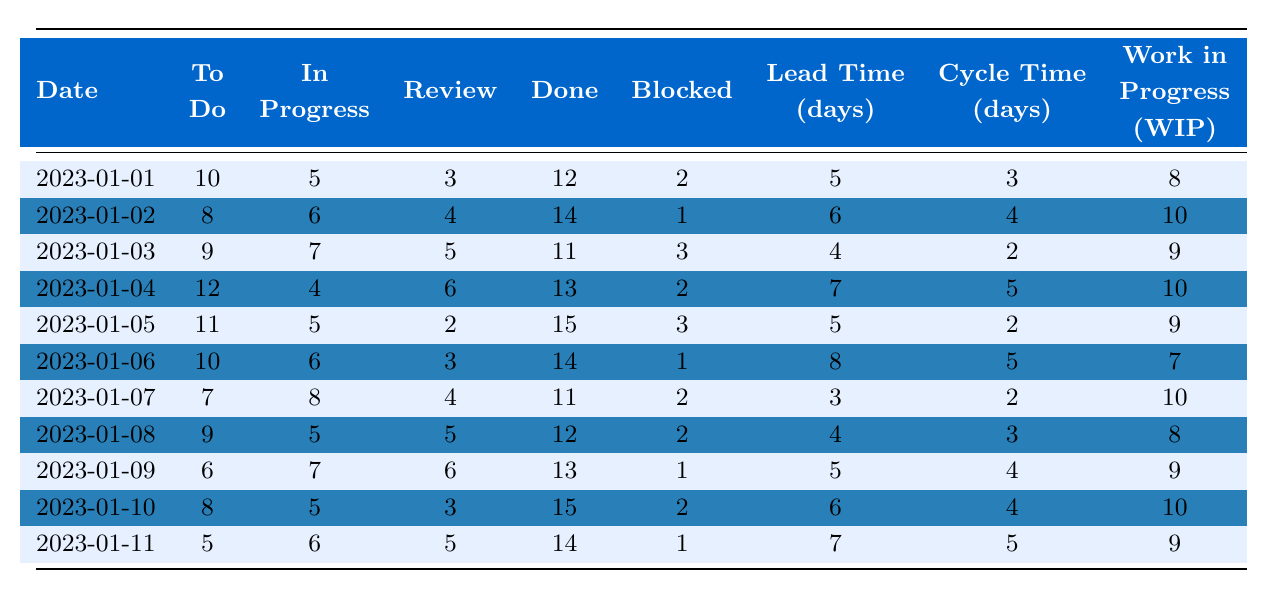What is the total number of tasks marked as "Done" on January 5, 2023? Referring to the table, the value listed under "Done" for January 5, 2023, is 15.
Answer: 15 What was the number of blocked tasks on January 9, 2023? The table shows that there was 1 task marked as "Blocked" on January 9, 2023.
Answer: 1 What was the average "Lead Time" for the tasks over the recorded days? To find the average, sum the "Lead Time" values: (5 + 6 + 4 + 7 + 5 + 8 + 3 + 4 + 5 + 6 + 7) = 60. There are 11 days, so the average is 60 / 11 ≈ 5.45.
Answer: 5.45 On which date was the highest "Cycle Time" recorded? Checking the "Cycle Time" values, the highest recorded value is 8 days on January 6, 2023, where it is listed.
Answer: January 6, 2023 How did the number of "To Do" tasks change from January 1 to January 11? On January 1, there were 10 "To Do" tasks, and on January 11, there were 5 "To Do" tasks. The change is 10 - 5 = 5 fewer tasks.
Answer: 5 fewer tasks What is the total number of tasks across all stages on January 4, 2023? The total is calculated by summing the values in each column on January 4, 2023: (12 + 4 + 6 + 13 + 2) = 37 tasks.
Answer: 37 tasks Was there ever a day when the "Work in Progress (WIP)" was less than 8? Checking the table, on January 6, there were 7 tasks in "Work in Progress," confirming that it was indeed below 8.
Answer: Yes What was the day with the highest number of "In Progress" tasks? The highest "In Progress" count can be found on January 7, 2023, where it lists 8 tasks.
Answer: January 7, 2023 What is the trend in "Blocked" tasks over the recorded dates? Observing the "Blocked" tasks values from the table: (2, 1, 3, 2, 3, 1, 2, 2, 1, 2, 1) shows no clear upward or downward trend, as it fluctuates.
Answer: Fluctuating, no clear trend Calculate the total "Cycle Time" over the period and check if it exceeds 50. The total Cycle Time is calculated as follows: (3 + 4 + 2 + 5 + 2 + 5 + 2 + 3 + 4 + 4 + 5) = 45. Since 45 is less than 50, it does not exceed.
Answer: No, it does not exceed 50 